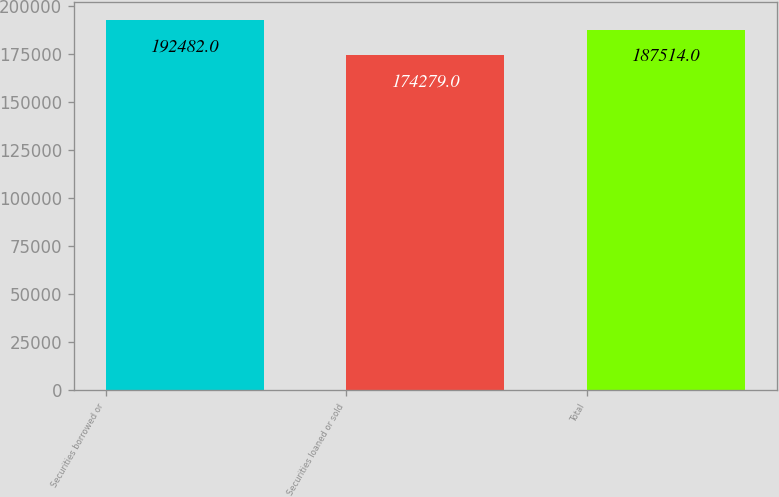Convert chart to OTSL. <chart><loc_0><loc_0><loc_500><loc_500><bar_chart><fcel>Securities borrowed or<fcel>Securities loaned or sold<fcel>Total<nl><fcel>192482<fcel>174279<fcel>187514<nl></chart> 